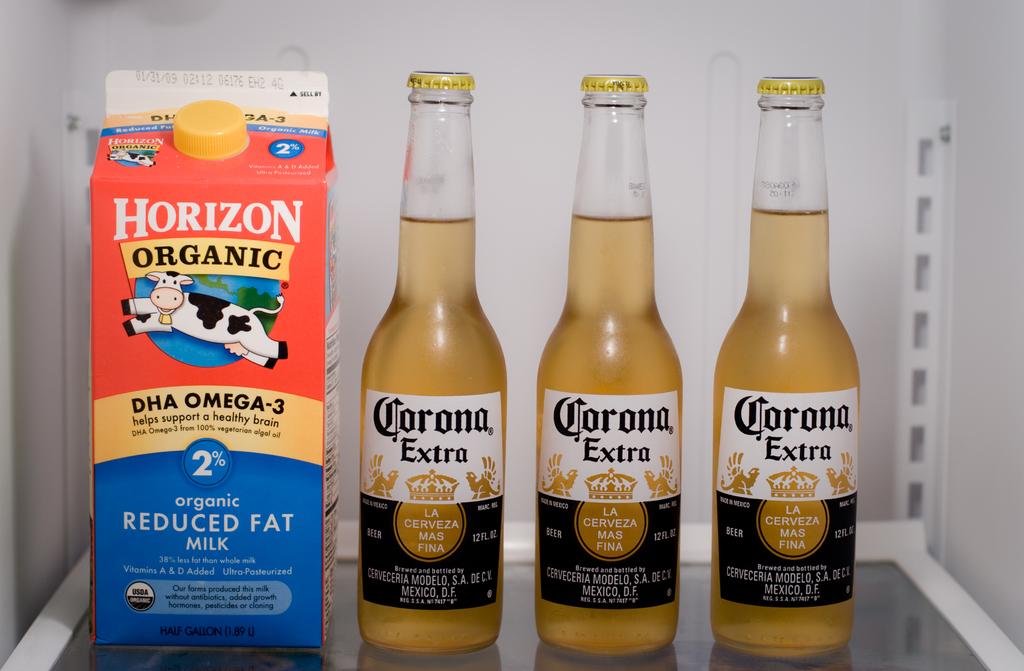What type of beer is in the fridge?
Ensure brevity in your answer.  Corona extra. What type of milk is in the fridge?
Provide a succinct answer. Horizon. 